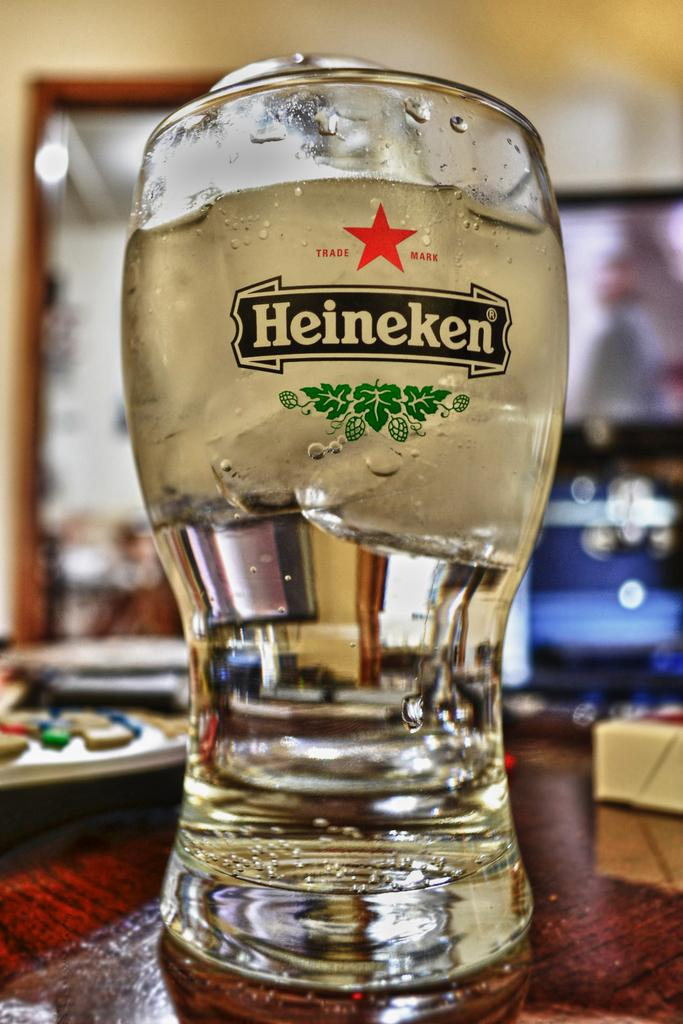<image>
Render a clear and concise summary of the photo. A Heineken glass is filled with ice cold water 